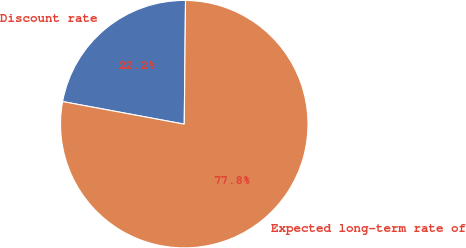Convert chart. <chart><loc_0><loc_0><loc_500><loc_500><pie_chart><fcel>Discount rate<fcel>Expected long-term rate of<nl><fcel>22.24%<fcel>77.76%<nl></chart> 